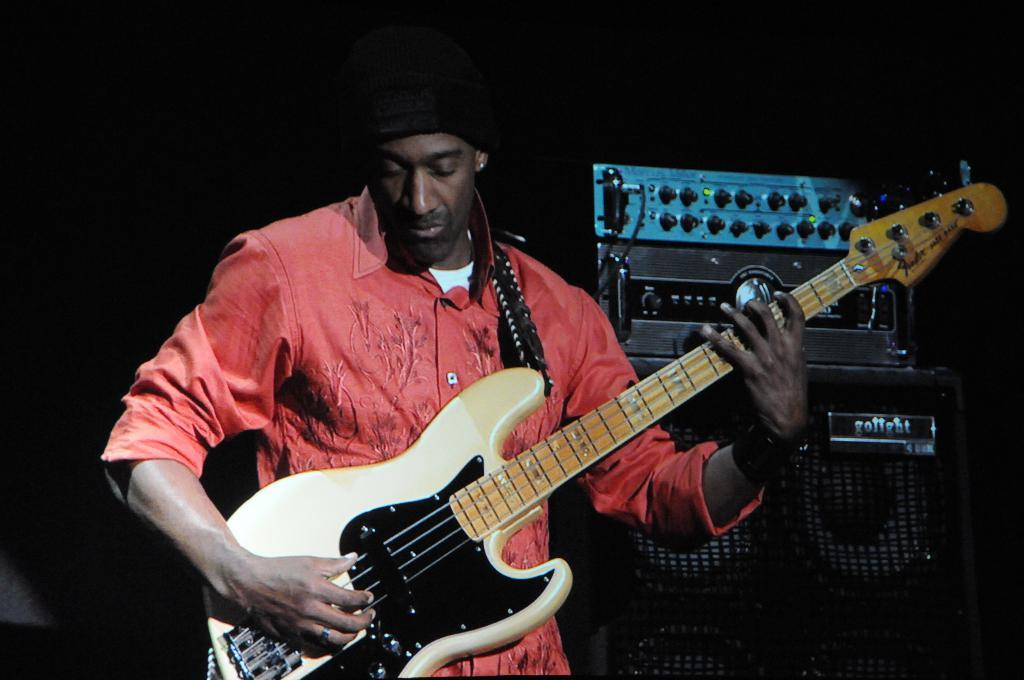What is the person in the image doing? The person in the image is playing a musical instrument. What can be seen to the right of the person? There is an electronic device to the right of the person. What is the color of the background in the image? The background of the image is black. Where is the toothpaste located in the image? There is no toothpaste present in the image. What type of appliance can be seen in the image? There is no appliance visible in the image. 